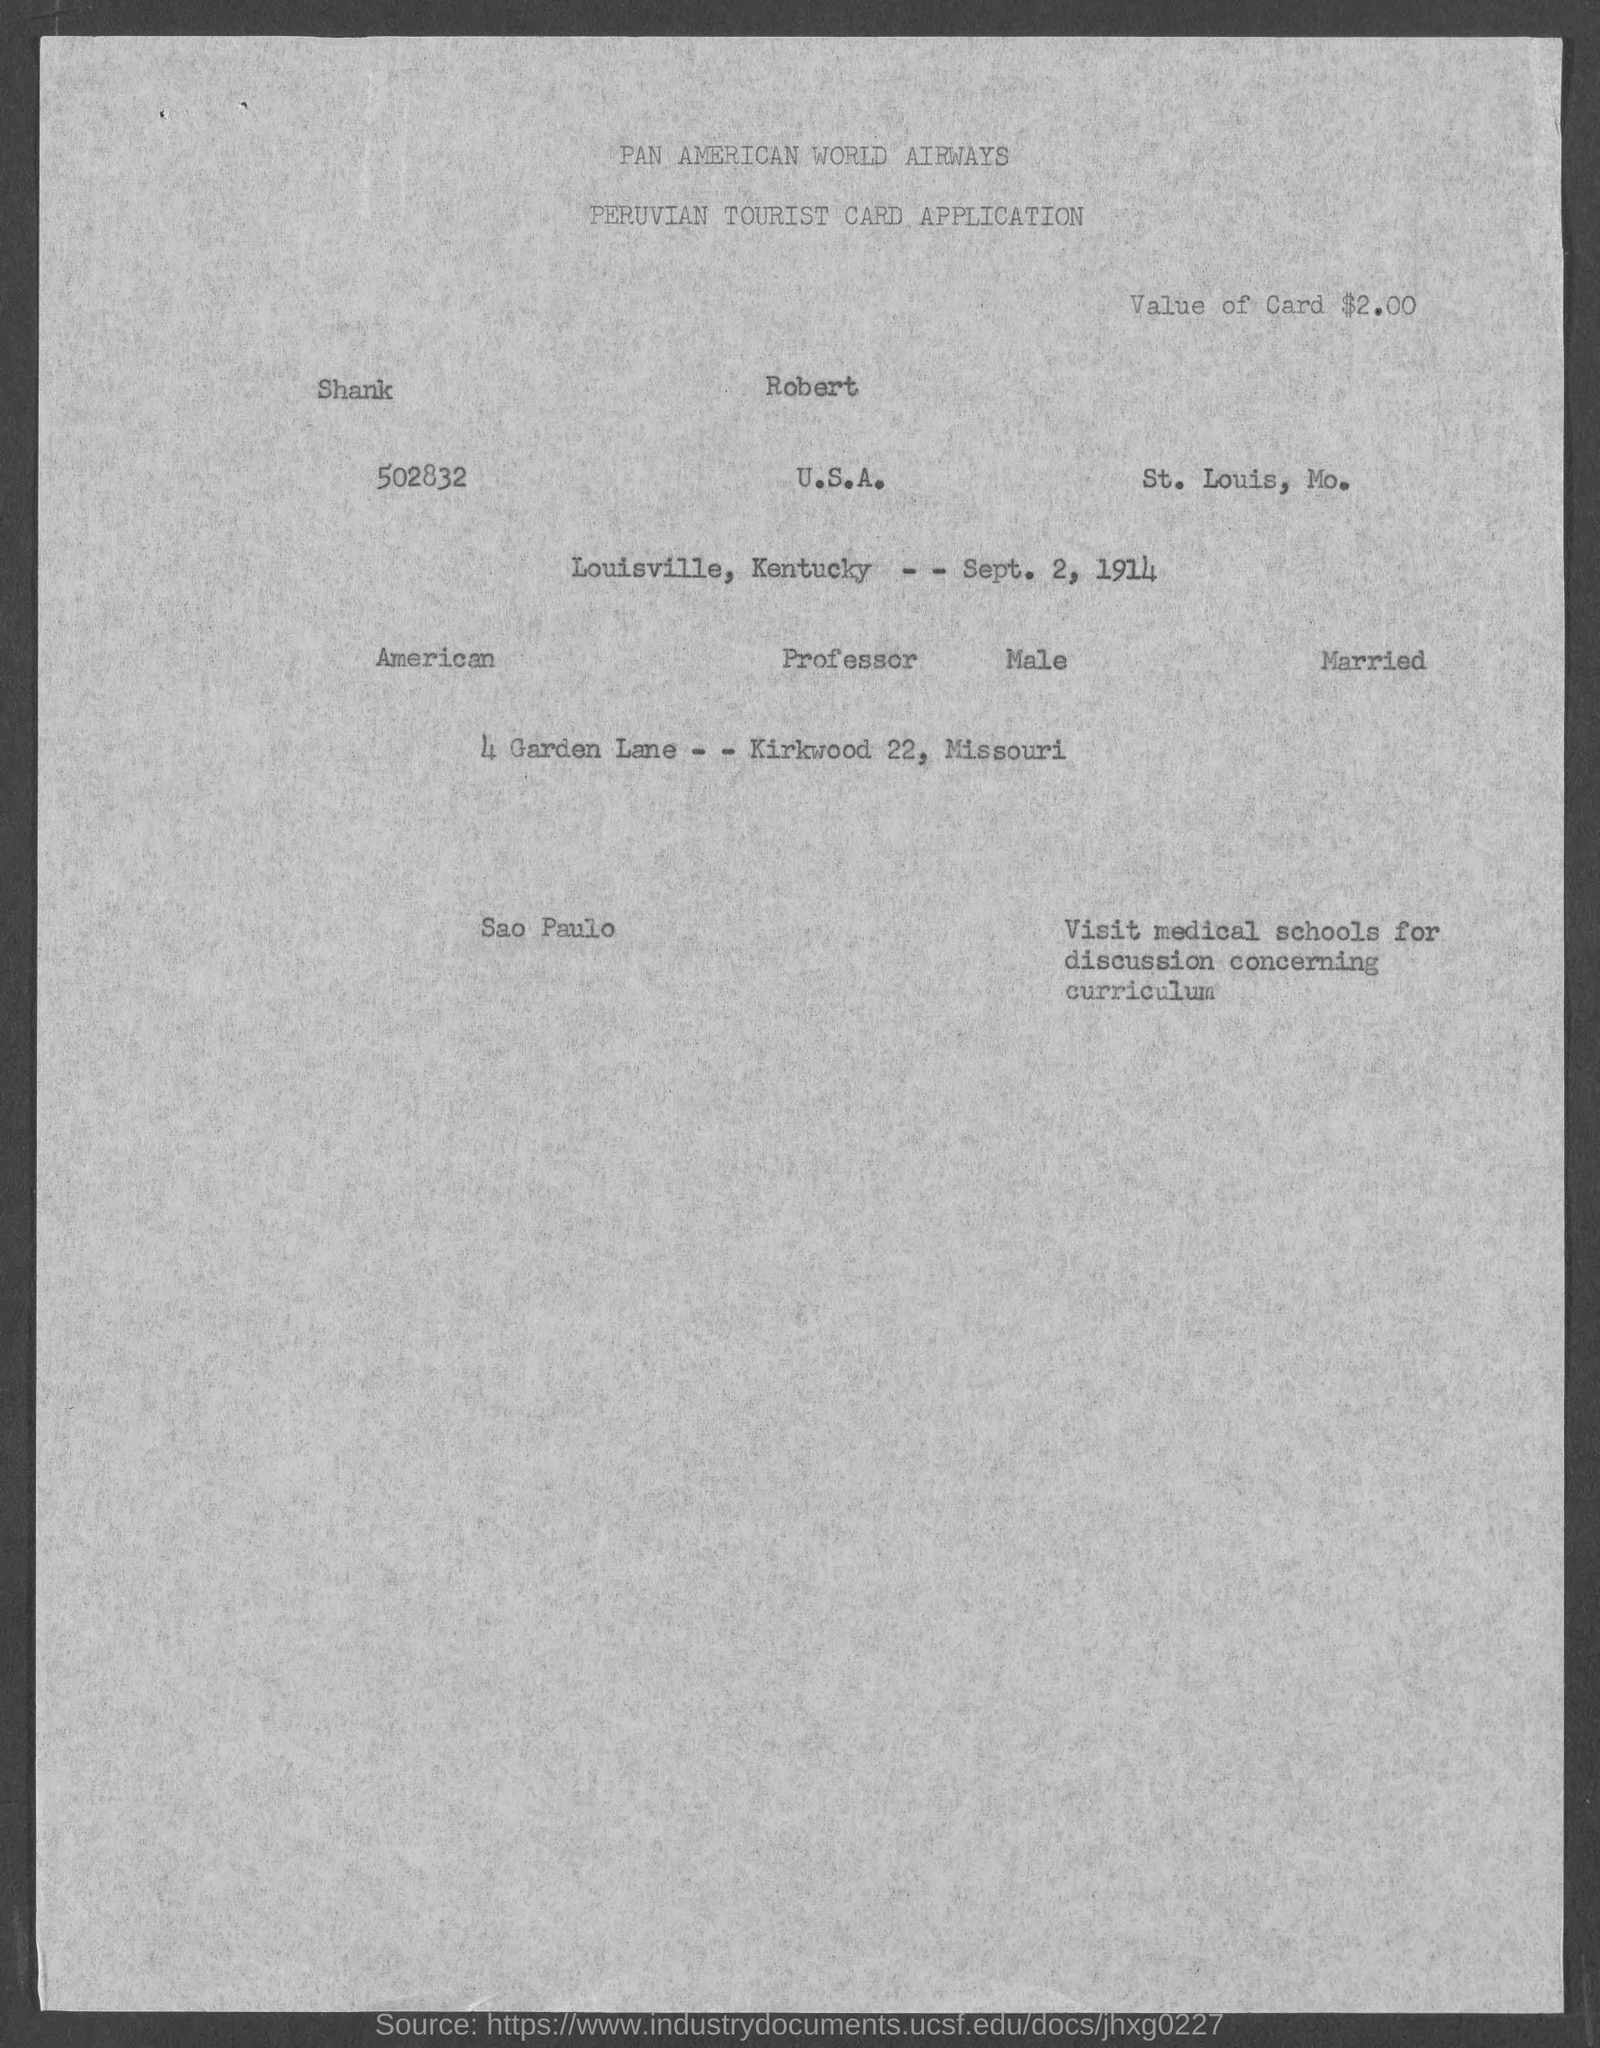What is the value of card given in the application?
Give a very brief answer. $2.00. What is the travel date mentioned in the application?
Give a very brief answer. Sept. 2, 1914. 